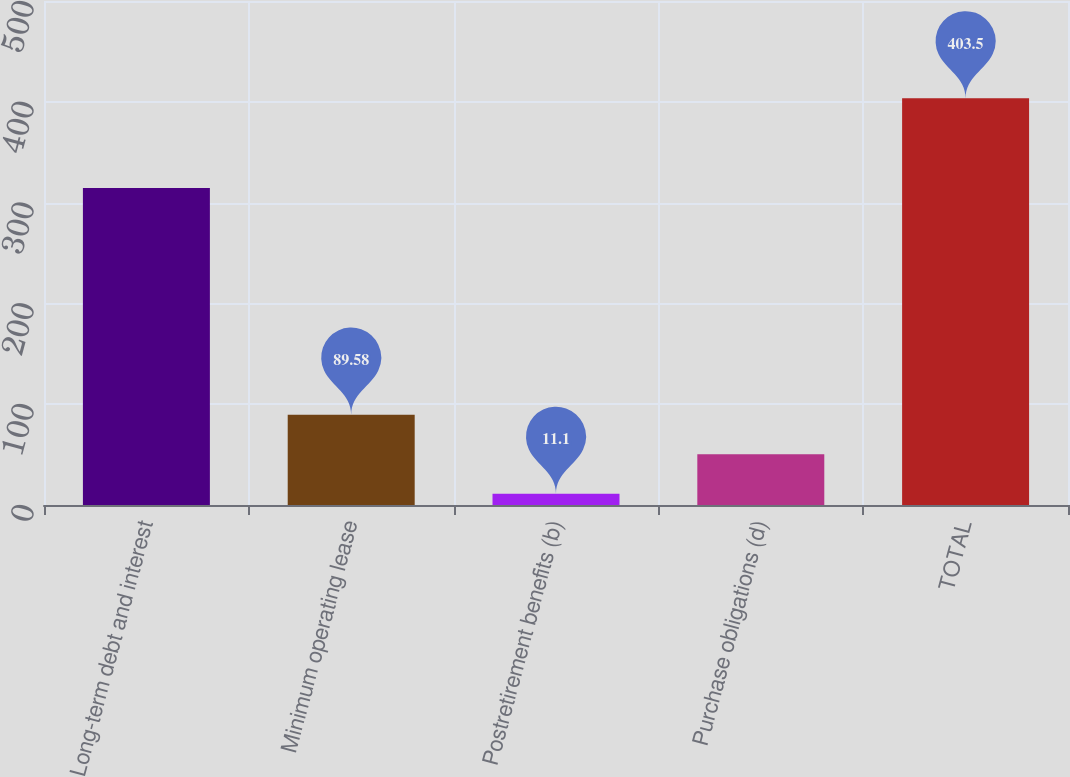<chart> <loc_0><loc_0><loc_500><loc_500><bar_chart><fcel>Long-term debt and interest<fcel>Minimum operating lease<fcel>Postretirement benefits (b)<fcel>Purchase obligations (d)<fcel>TOTAL<nl><fcel>314.6<fcel>89.58<fcel>11.1<fcel>50.34<fcel>403.5<nl></chart> 